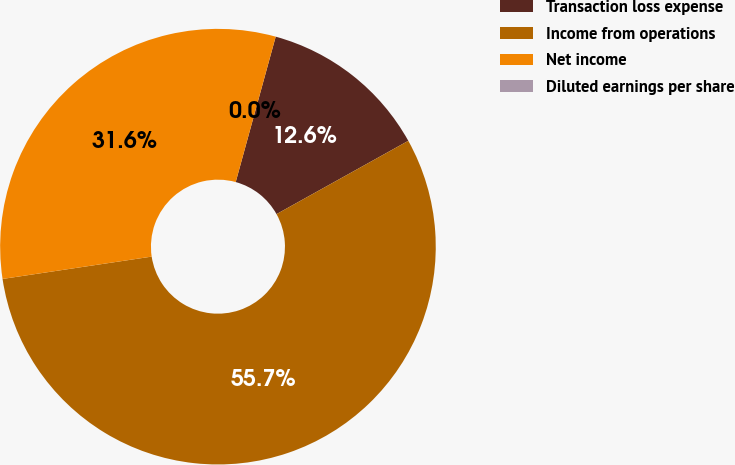Convert chart. <chart><loc_0><loc_0><loc_500><loc_500><pie_chart><fcel>Transaction loss expense<fcel>Income from operations<fcel>Net income<fcel>Diluted earnings per share<nl><fcel>12.65%<fcel>55.71%<fcel>31.64%<fcel>0.0%<nl></chart> 